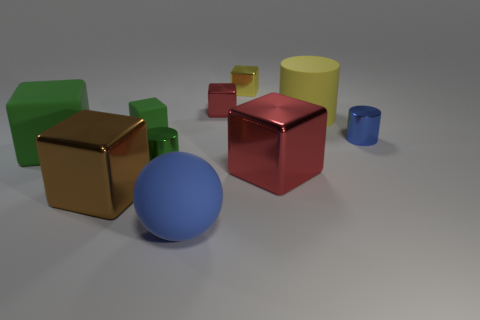Add 8 matte balls. How many matte balls exist? 9 Subtract all green cylinders. How many cylinders are left? 2 Subtract all tiny yellow blocks. How many blocks are left? 5 Subtract 1 red blocks. How many objects are left? 9 Subtract all blocks. How many objects are left? 4 Subtract 5 blocks. How many blocks are left? 1 Subtract all green cylinders. Subtract all blue blocks. How many cylinders are left? 2 Subtract all purple cylinders. How many yellow cubes are left? 1 Subtract all big matte things. Subtract all yellow cylinders. How many objects are left? 6 Add 3 large metallic blocks. How many large metallic blocks are left? 5 